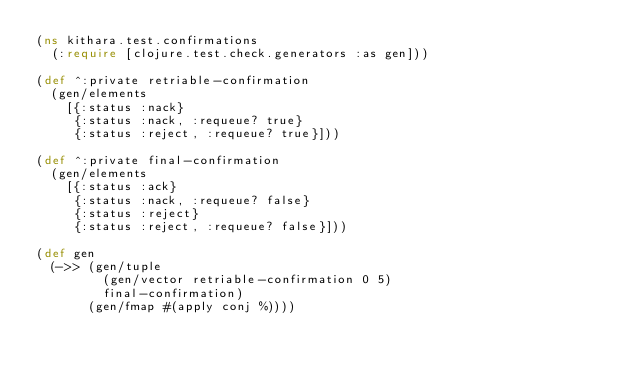<code> <loc_0><loc_0><loc_500><loc_500><_Clojure_>(ns kithara.test.confirmations
  (:require [clojure.test.check.generators :as gen]))

(def ^:private retriable-confirmation
  (gen/elements
    [{:status :nack}
     {:status :nack, :requeue? true}
     {:status :reject, :requeue? true}]))

(def ^:private final-confirmation
  (gen/elements
    [{:status :ack}
     {:status :nack, :requeue? false}
     {:status :reject}
     {:status :reject, :requeue? false}]))

(def gen
  (->> (gen/tuple
         (gen/vector retriable-confirmation 0 5)
         final-confirmation)
       (gen/fmap #(apply conj %))))
</code> 